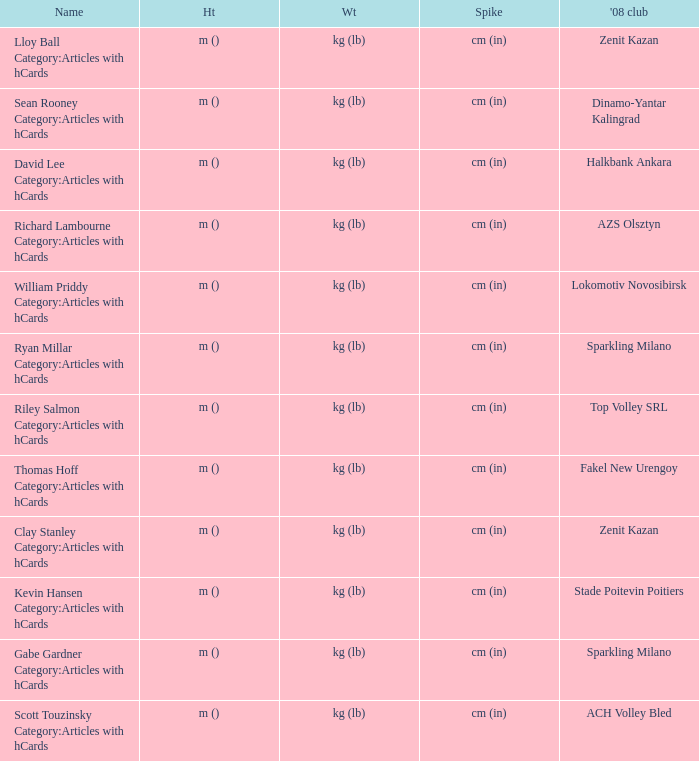Can you give me this table as a dict? {'header': ['Name', 'Ht', 'Wt', 'Spike', "'08 club"], 'rows': [['Lloy Ball Category:Articles with hCards', 'm ()', 'kg (lb)', 'cm (in)', 'Zenit Kazan'], ['Sean Rooney Category:Articles with hCards', 'm ()', 'kg (lb)', 'cm (in)', 'Dinamo-Yantar Kalingrad'], ['David Lee Category:Articles with hCards', 'm ()', 'kg (lb)', 'cm (in)', 'Halkbank Ankara'], ['Richard Lambourne Category:Articles with hCards', 'm ()', 'kg (lb)', 'cm (in)', 'AZS Olsztyn'], ['William Priddy Category:Articles with hCards', 'm ()', 'kg (lb)', 'cm (in)', 'Lokomotiv Novosibirsk'], ['Ryan Millar Category:Articles with hCards', 'm ()', 'kg (lb)', 'cm (in)', 'Sparkling Milano'], ['Riley Salmon Category:Articles with hCards', 'm ()', 'kg (lb)', 'cm (in)', 'Top Volley SRL'], ['Thomas Hoff Category:Articles with hCards', 'm ()', 'kg (lb)', 'cm (in)', 'Fakel New Urengoy'], ['Clay Stanley Category:Articles with hCards', 'm ()', 'kg (lb)', 'cm (in)', 'Zenit Kazan'], ['Kevin Hansen Category:Articles with hCards', 'm ()', 'kg (lb)', 'cm (in)', 'Stade Poitevin Poitiers'], ['Gabe Gardner Category:Articles with hCards', 'm ()', 'kg (lb)', 'cm (in)', 'Sparkling Milano'], ['Scott Touzinsky Category:Articles with hCards', 'm ()', 'kg (lb)', 'cm (in)', 'ACH Volley Bled']]} What is the spike for the 2008 club of Lokomotiv Novosibirsk? Cm (in). 